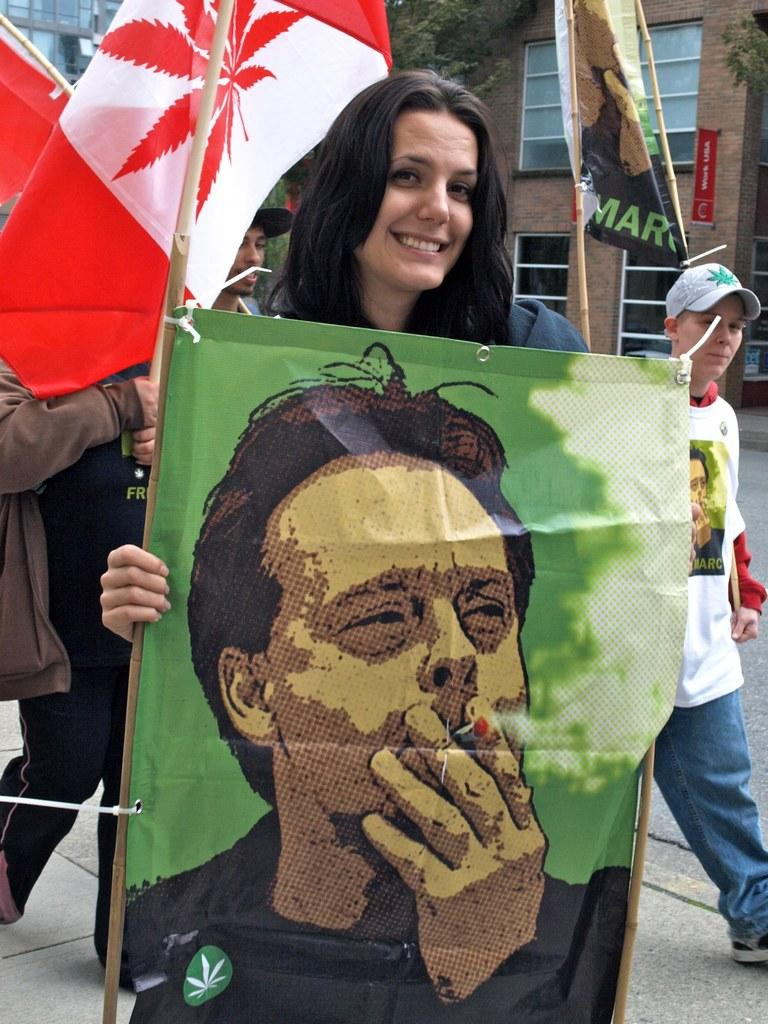How many people are present in the image? There are four persons in the image. What are the persons holding in the image? The persons are holding banners. What can be seen in the background of the image? There are buildings and trees in the background of the image. What type of operation is being performed by the persons in the image? There is no operation being performed in the image; the persons are holding banners. Can you tell me the flight number of the plane in the image? There is no plane present in the image, so it is not possible to determine a flight number. 